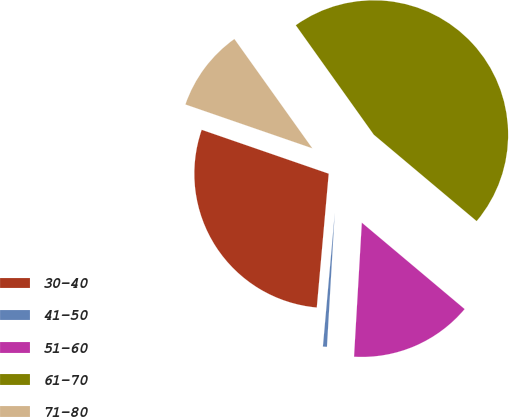Convert chart to OTSL. <chart><loc_0><loc_0><loc_500><loc_500><pie_chart><fcel>30-40<fcel>41-50<fcel>51-60<fcel>61-70<fcel>71-80<nl><fcel>28.88%<fcel>0.49%<fcel>14.8%<fcel>45.98%<fcel>9.85%<nl></chart> 